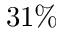Convert formula to latex. <formula><loc_0><loc_0><loc_500><loc_500>3 1 \%</formula> 